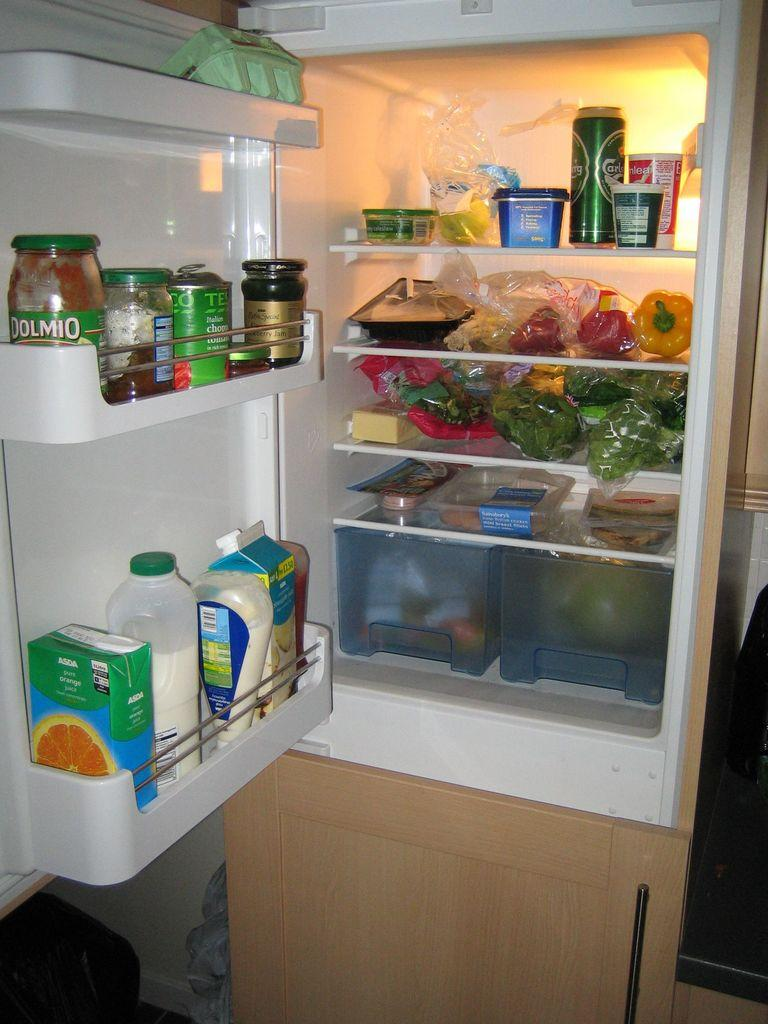What is the setting of the image? The image is of a refrigerator's interior. What types of food items can be seen in the refrigerator? There are milk products, juices, eatables, fruits, and vegetables in the refrigerator. Are there any other items visible in the refrigerator? Yes, there are other items on the shelves of the refrigerator. Can you tell me how many toads are sitting on the shelves of the refrigerator? There are no toads present in the image; it shows the interior of a refrigerator with various food items and other items. Is it raining inside the refrigerator? No, it is not raining inside the refrigerator; the image shows a dry environment with food items and other items on the shelves. 